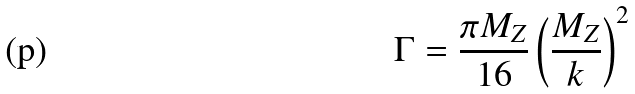<formula> <loc_0><loc_0><loc_500><loc_500>\Gamma = \frac { \pi M _ { Z } } { 1 6 } \left ( \frac { M _ { Z } } { k } \right ) ^ { 2 }</formula> 